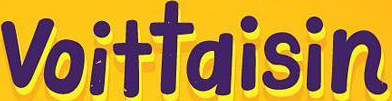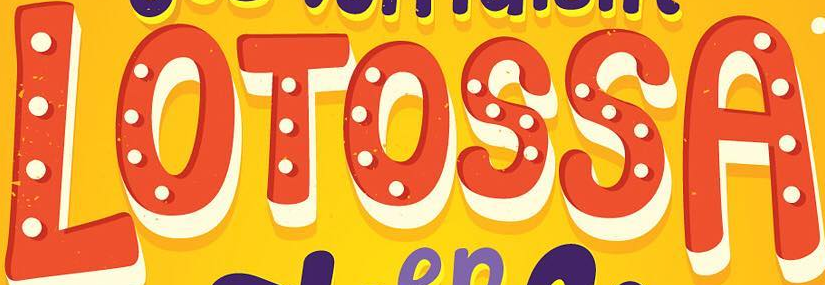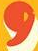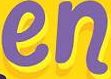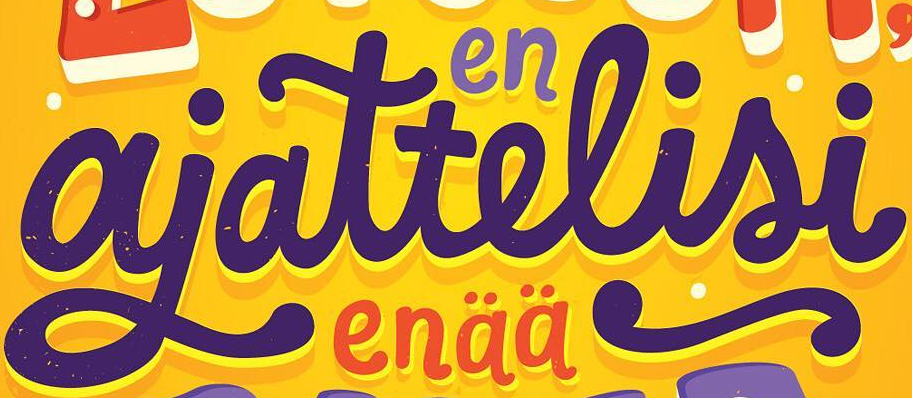Read the text content from these images in order, separated by a semicolon. voittaisin; LOTOSSA; ,; en; ajattelisi 